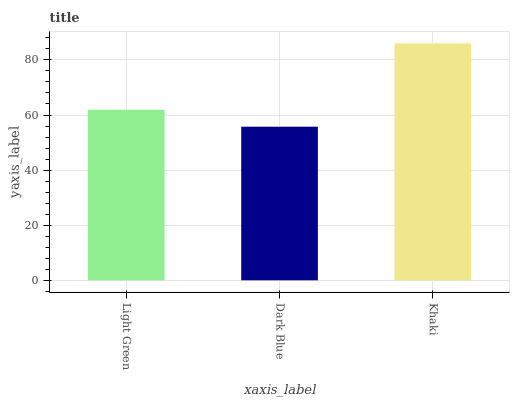Is Dark Blue the minimum?
Answer yes or no. Yes. Is Khaki the maximum?
Answer yes or no. Yes. Is Khaki the minimum?
Answer yes or no. No. Is Dark Blue the maximum?
Answer yes or no. No. Is Khaki greater than Dark Blue?
Answer yes or no. Yes. Is Dark Blue less than Khaki?
Answer yes or no. Yes. Is Dark Blue greater than Khaki?
Answer yes or no. No. Is Khaki less than Dark Blue?
Answer yes or no. No. Is Light Green the high median?
Answer yes or no. Yes. Is Light Green the low median?
Answer yes or no. Yes. Is Khaki the high median?
Answer yes or no. No. Is Dark Blue the low median?
Answer yes or no. No. 